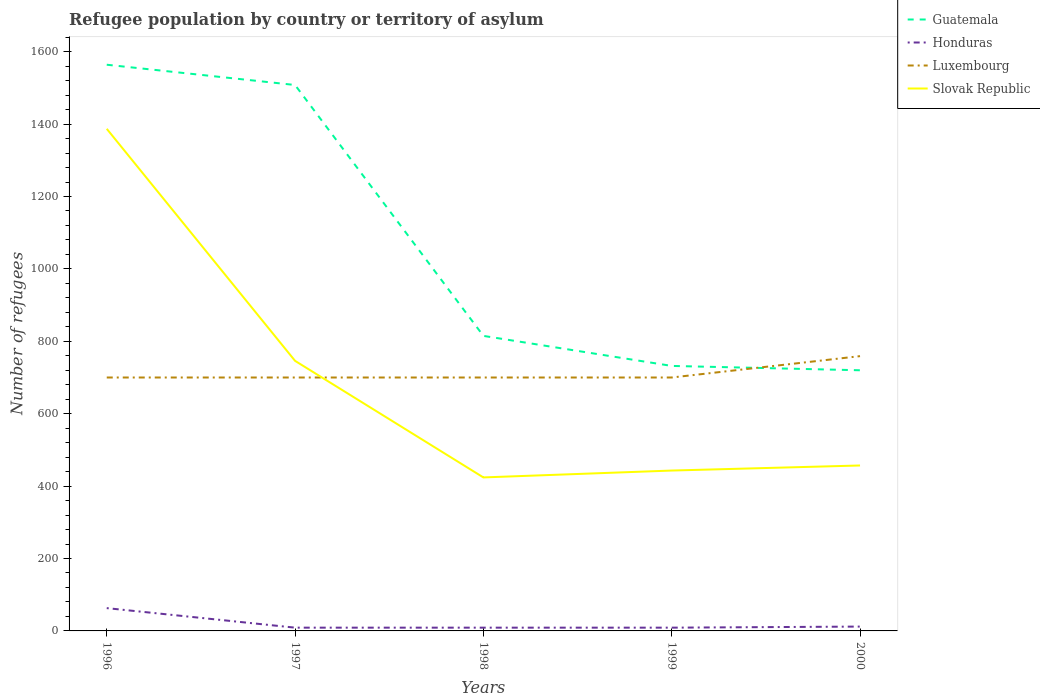Across all years, what is the maximum number of refugees in Luxembourg?
Give a very brief answer. 700. What is the difference between the highest and the second highest number of refugees in Honduras?
Provide a short and direct response. 54. How many lines are there?
Offer a very short reply. 4. What is the difference between two consecutive major ticks on the Y-axis?
Give a very brief answer. 200. Are the values on the major ticks of Y-axis written in scientific E-notation?
Make the answer very short. No. Does the graph contain grids?
Ensure brevity in your answer.  No. How many legend labels are there?
Keep it short and to the point. 4. How are the legend labels stacked?
Make the answer very short. Vertical. What is the title of the graph?
Your response must be concise. Refugee population by country or territory of asylum. What is the label or title of the X-axis?
Make the answer very short. Years. What is the label or title of the Y-axis?
Ensure brevity in your answer.  Number of refugees. What is the Number of refugees in Guatemala in 1996?
Make the answer very short. 1564. What is the Number of refugees of Honduras in 1996?
Your response must be concise. 63. What is the Number of refugees of Luxembourg in 1996?
Give a very brief answer. 700. What is the Number of refugees in Slovak Republic in 1996?
Your response must be concise. 1387. What is the Number of refugees in Guatemala in 1997?
Your response must be concise. 1508. What is the Number of refugees of Luxembourg in 1997?
Offer a very short reply. 700. What is the Number of refugees in Slovak Republic in 1997?
Offer a very short reply. 746. What is the Number of refugees in Guatemala in 1998?
Your response must be concise. 815. What is the Number of refugees in Luxembourg in 1998?
Provide a succinct answer. 700. What is the Number of refugees of Slovak Republic in 1998?
Offer a terse response. 424. What is the Number of refugees of Guatemala in 1999?
Offer a terse response. 732. What is the Number of refugees of Luxembourg in 1999?
Keep it short and to the point. 700. What is the Number of refugees of Slovak Republic in 1999?
Your answer should be compact. 443. What is the Number of refugees in Guatemala in 2000?
Offer a terse response. 720. What is the Number of refugees in Luxembourg in 2000?
Provide a succinct answer. 759. What is the Number of refugees of Slovak Republic in 2000?
Provide a succinct answer. 457. Across all years, what is the maximum Number of refugees in Guatemala?
Keep it short and to the point. 1564. Across all years, what is the maximum Number of refugees of Honduras?
Ensure brevity in your answer.  63. Across all years, what is the maximum Number of refugees of Luxembourg?
Give a very brief answer. 759. Across all years, what is the maximum Number of refugees in Slovak Republic?
Offer a terse response. 1387. Across all years, what is the minimum Number of refugees of Guatemala?
Offer a terse response. 720. Across all years, what is the minimum Number of refugees in Honduras?
Keep it short and to the point. 9. Across all years, what is the minimum Number of refugees in Luxembourg?
Keep it short and to the point. 700. Across all years, what is the minimum Number of refugees in Slovak Republic?
Ensure brevity in your answer.  424. What is the total Number of refugees of Guatemala in the graph?
Provide a succinct answer. 5339. What is the total Number of refugees of Honduras in the graph?
Your answer should be very brief. 102. What is the total Number of refugees of Luxembourg in the graph?
Make the answer very short. 3559. What is the total Number of refugees in Slovak Republic in the graph?
Give a very brief answer. 3457. What is the difference between the Number of refugees in Guatemala in 1996 and that in 1997?
Offer a very short reply. 56. What is the difference between the Number of refugees in Honduras in 1996 and that in 1997?
Provide a succinct answer. 54. What is the difference between the Number of refugees of Luxembourg in 1996 and that in 1997?
Ensure brevity in your answer.  0. What is the difference between the Number of refugees of Slovak Republic in 1996 and that in 1997?
Offer a very short reply. 641. What is the difference between the Number of refugees in Guatemala in 1996 and that in 1998?
Keep it short and to the point. 749. What is the difference between the Number of refugees of Honduras in 1996 and that in 1998?
Make the answer very short. 54. What is the difference between the Number of refugees of Slovak Republic in 1996 and that in 1998?
Offer a very short reply. 963. What is the difference between the Number of refugees in Guatemala in 1996 and that in 1999?
Provide a short and direct response. 832. What is the difference between the Number of refugees of Luxembourg in 1996 and that in 1999?
Make the answer very short. 0. What is the difference between the Number of refugees of Slovak Republic in 1996 and that in 1999?
Your response must be concise. 944. What is the difference between the Number of refugees in Guatemala in 1996 and that in 2000?
Keep it short and to the point. 844. What is the difference between the Number of refugees in Luxembourg in 1996 and that in 2000?
Offer a terse response. -59. What is the difference between the Number of refugees of Slovak Republic in 1996 and that in 2000?
Your answer should be compact. 930. What is the difference between the Number of refugees in Guatemala in 1997 and that in 1998?
Provide a succinct answer. 693. What is the difference between the Number of refugees of Honduras in 1997 and that in 1998?
Provide a succinct answer. 0. What is the difference between the Number of refugees of Slovak Republic in 1997 and that in 1998?
Offer a very short reply. 322. What is the difference between the Number of refugees in Guatemala in 1997 and that in 1999?
Offer a terse response. 776. What is the difference between the Number of refugees of Honduras in 1997 and that in 1999?
Keep it short and to the point. 0. What is the difference between the Number of refugees of Slovak Republic in 1997 and that in 1999?
Your answer should be compact. 303. What is the difference between the Number of refugees in Guatemala in 1997 and that in 2000?
Give a very brief answer. 788. What is the difference between the Number of refugees of Luxembourg in 1997 and that in 2000?
Provide a succinct answer. -59. What is the difference between the Number of refugees in Slovak Republic in 1997 and that in 2000?
Your answer should be very brief. 289. What is the difference between the Number of refugees in Guatemala in 1998 and that in 1999?
Give a very brief answer. 83. What is the difference between the Number of refugees in Honduras in 1998 and that in 1999?
Keep it short and to the point. 0. What is the difference between the Number of refugees of Luxembourg in 1998 and that in 1999?
Make the answer very short. 0. What is the difference between the Number of refugees of Slovak Republic in 1998 and that in 1999?
Make the answer very short. -19. What is the difference between the Number of refugees in Guatemala in 1998 and that in 2000?
Ensure brevity in your answer.  95. What is the difference between the Number of refugees in Honduras in 1998 and that in 2000?
Ensure brevity in your answer.  -3. What is the difference between the Number of refugees in Luxembourg in 1998 and that in 2000?
Offer a very short reply. -59. What is the difference between the Number of refugees in Slovak Republic in 1998 and that in 2000?
Make the answer very short. -33. What is the difference between the Number of refugees in Guatemala in 1999 and that in 2000?
Provide a succinct answer. 12. What is the difference between the Number of refugees of Luxembourg in 1999 and that in 2000?
Your answer should be compact. -59. What is the difference between the Number of refugees in Guatemala in 1996 and the Number of refugees in Honduras in 1997?
Offer a very short reply. 1555. What is the difference between the Number of refugees of Guatemala in 1996 and the Number of refugees of Luxembourg in 1997?
Offer a terse response. 864. What is the difference between the Number of refugees of Guatemala in 1996 and the Number of refugees of Slovak Republic in 1997?
Keep it short and to the point. 818. What is the difference between the Number of refugees of Honduras in 1996 and the Number of refugees of Luxembourg in 1997?
Make the answer very short. -637. What is the difference between the Number of refugees in Honduras in 1996 and the Number of refugees in Slovak Republic in 1997?
Your answer should be compact. -683. What is the difference between the Number of refugees of Luxembourg in 1996 and the Number of refugees of Slovak Republic in 1997?
Your answer should be very brief. -46. What is the difference between the Number of refugees of Guatemala in 1996 and the Number of refugees of Honduras in 1998?
Your response must be concise. 1555. What is the difference between the Number of refugees in Guatemala in 1996 and the Number of refugees in Luxembourg in 1998?
Your answer should be compact. 864. What is the difference between the Number of refugees of Guatemala in 1996 and the Number of refugees of Slovak Republic in 1998?
Your response must be concise. 1140. What is the difference between the Number of refugees in Honduras in 1996 and the Number of refugees in Luxembourg in 1998?
Ensure brevity in your answer.  -637. What is the difference between the Number of refugees of Honduras in 1996 and the Number of refugees of Slovak Republic in 1998?
Give a very brief answer. -361. What is the difference between the Number of refugees in Luxembourg in 1996 and the Number of refugees in Slovak Republic in 1998?
Provide a short and direct response. 276. What is the difference between the Number of refugees in Guatemala in 1996 and the Number of refugees in Honduras in 1999?
Your answer should be very brief. 1555. What is the difference between the Number of refugees in Guatemala in 1996 and the Number of refugees in Luxembourg in 1999?
Offer a terse response. 864. What is the difference between the Number of refugees of Guatemala in 1996 and the Number of refugees of Slovak Republic in 1999?
Your response must be concise. 1121. What is the difference between the Number of refugees in Honduras in 1996 and the Number of refugees in Luxembourg in 1999?
Your response must be concise. -637. What is the difference between the Number of refugees in Honduras in 1996 and the Number of refugees in Slovak Republic in 1999?
Your answer should be very brief. -380. What is the difference between the Number of refugees in Luxembourg in 1996 and the Number of refugees in Slovak Republic in 1999?
Your answer should be very brief. 257. What is the difference between the Number of refugees in Guatemala in 1996 and the Number of refugees in Honduras in 2000?
Your answer should be very brief. 1552. What is the difference between the Number of refugees of Guatemala in 1996 and the Number of refugees of Luxembourg in 2000?
Your answer should be very brief. 805. What is the difference between the Number of refugees of Guatemala in 1996 and the Number of refugees of Slovak Republic in 2000?
Provide a short and direct response. 1107. What is the difference between the Number of refugees in Honduras in 1996 and the Number of refugees in Luxembourg in 2000?
Give a very brief answer. -696. What is the difference between the Number of refugees in Honduras in 1996 and the Number of refugees in Slovak Republic in 2000?
Your answer should be compact. -394. What is the difference between the Number of refugees of Luxembourg in 1996 and the Number of refugees of Slovak Republic in 2000?
Give a very brief answer. 243. What is the difference between the Number of refugees of Guatemala in 1997 and the Number of refugees of Honduras in 1998?
Keep it short and to the point. 1499. What is the difference between the Number of refugees in Guatemala in 1997 and the Number of refugees in Luxembourg in 1998?
Your answer should be very brief. 808. What is the difference between the Number of refugees in Guatemala in 1997 and the Number of refugees in Slovak Republic in 1998?
Your answer should be compact. 1084. What is the difference between the Number of refugees in Honduras in 1997 and the Number of refugees in Luxembourg in 1998?
Offer a terse response. -691. What is the difference between the Number of refugees in Honduras in 1997 and the Number of refugees in Slovak Republic in 1998?
Keep it short and to the point. -415. What is the difference between the Number of refugees in Luxembourg in 1997 and the Number of refugees in Slovak Republic in 1998?
Ensure brevity in your answer.  276. What is the difference between the Number of refugees in Guatemala in 1997 and the Number of refugees in Honduras in 1999?
Give a very brief answer. 1499. What is the difference between the Number of refugees of Guatemala in 1997 and the Number of refugees of Luxembourg in 1999?
Give a very brief answer. 808. What is the difference between the Number of refugees of Guatemala in 1997 and the Number of refugees of Slovak Republic in 1999?
Provide a short and direct response. 1065. What is the difference between the Number of refugees of Honduras in 1997 and the Number of refugees of Luxembourg in 1999?
Make the answer very short. -691. What is the difference between the Number of refugees of Honduras in 1997 and the Number of refugees of Slovak Republic in 1999?
Keep it short and to the point. -434. What is the difference between the Number of refugees in Luxembourg in 1997 and the Number of refugees in Slovak Republic in 1999?
Your response must be concise. 257. What is the difference between the Number of refugees in Guatemala in 1997 and the Number of refugees in Honduras in 2000?
Provide a short and direct response. 1496. What is the difference between the Number of refugees of Guatemala in 1997 and the Number of refugees of Luxembourg in 2000?
Provide a short and direct response. 749. What is the difference between the Number of refugees in Guatemala in 1997 and the Number of refugees in Slovak Republic in 2000?
Give a very brief answer. 1051. What is the difference between the Number of refugees of Honduras in 1997 and the Number of refugees of Luxembourg in 2000?
Provide a short and direct response. -750. What is the difference between the Number of refugees of Honduras in 1997 and the Number of refugees of Slovak Republic in 2000?
Provide a succinct answer. -448. What is the difference between the Number of refugees of Luxembourg in 1997 and the Number of refugees of Slovak Republic in 2000?
Ensure brevity in your answer.  243. What is the difference between the Number of refugees of Guatemala in 1998 and the Number of refugees of Honduras in 1999?
Your answer should be very brief. 806. What is the difference between the Number of refugees in Guatemala in 1998 and the Number of refugees in Luxembourg in 1999?
Your answer should be very brief. 115. What is the difference between the Number of refugees in Guatemala in 1998 and the Number of refugees in Slovak Republic in 1999?
Ensure brevity in your answer.  372. What is the difference between the Number of refugees in Honduras in 1998 and the Number of refugees in Luxembourg in 1999?
Your answer should be very brief. -691. What is the difference between the Number of refugees of Honduras in 1998 and the Number of refugees of Slovak Republic in 1999?
Offer a terse response. -434. What is the difference between the Number of refugees of Luxembourg in 1998 and the Number of refugees of Slovak Republic in 1999?
Make the answer very short. 257. What is the difference between the Number of refugees in Guatemala in 1998 and the Number of refugees in Honduras in 2000?
Provide a succinct answer. 803. What is the difference between the Number of refugees of Guatemala in 1998 and the Number of refugees of Slovak Republic in 2000?
Your response must be concise. 358. What is the difference between the Number of refugees in Honduras in 1998 and the Number of refugees in Luxembourg in 2000?
Ensure brevity in your answer.  -750. What is the difference between the Number of refugees in Honduras in 1998 and the Number of refugees in Slovak Republic in 2000?
Your response must be concise. -448. What is the difference between the Number of refugees of Luxembourg in 1998 and the Number of refugees of Slovak Republic in 2000?
Give a very brief answer. 243. What is the difference between the Number of refugees of Guatemala in 1999 and the Number of refugees of Honduras in 2000?
Ensure brevity in your answer.  720. What is the difference between the Number of refugees in Guatemala in 1999 and the Number of refugees in Luxembourg in 2000?
Your response must be concise. -27. What is the difference between the Number of refugees in Guatemala in 1999 and the Number of refugees in Slovak Republic in 2000?
Your answer should be compact. 275. What is the difference between the Number of refugees in Honduras in 1999 and the Number of refugees in Luxembourg in 2000?
Offer a terse response. -750. What is the difference between the Number of refugees of Honduras in 1999 and the Number of refugees of Slovak Republic in 2000?
Make the answer very short. -448. What is the difference between the Number of refugees in Luxembourg in 1999 and the Number of refugees in Slovak Republic in 2000?
Your answer should be compact. 243. What is the average Number of refugees in Guatemala per year?
Your answer should be very brief. 1067.8. What is the average Number of refugees of Honduras per year?
Your answer should be very brief. 20.4. What is the average Number of refugees in Luxembourg per year?
Give a very brief answer. 711.8. What is the average Number of refugees of Slovak Republic per year?
Make the answer very short. 691.4. In the year 1996, what is the difference between the Number of refugees of Guatemala and Number of refugees of Honduras?
Your response must be concise. 1501. In the year 1996, what is the difference between the Number of refugees in Guatemala and Number of refugees in Luxembourg?
Give a very brief answer. 864. In the year 1996, what is the difference between the Number of refugees in Guatemala and Number of refugees in Slovak Republic?
Ensure brevity in your answer.  177. In the year 1996, what is the difference between the Number of refugees of Honduras and Number of refugees of Luxembourg?
Offer a terse response. -637. In the year 1996, what is the difference between the Number of refugees of Honduras and Number of refugees of Slovak Republic?
Your answer should be very brief. -1324. In the year 1996, what is the difference between the Number of refugees of Luxembourg and Number of refugees of Slovak Republic?
Your answer should be very brief. -687. In the year 1997, what is the difference between the Number of refugees of Guatemala and Number of refugees of Honduras?
Your answer should be very brief. 1499. In the year 1997, what is the difference between the Number of refugees of Guatemala and Number of refugees of Luxembourg?
Make the answer very short. 808. In the year 1997, what is the difference between the Number of refugees of Guatemala and Number of refugees of Slovak Republic?
Offer a terse response. 762. In the year 1997, what is the difference between the Number of refugees of Honduras and Number of refugees of Luxembourg?
Provide a succinct answer. -691. In the year 1997, what is the difference between the Number of refugees of Honduras and Number of refugees of Slovak Republic?
Your response must be concise. -737. In the year 1997, what is the difference between the Number of refugees in Luxembourg and Number of refugees in Slovak Republic?
Your answer should be compact. -46. In the year 1998, what is the difference between the Number of refugees in Guatemala and Number of refugees in Honduras?
Your answer should be compact. 806. In the year 1998, what is the difference between the Number of refugees in Guatemala and Number of refugees in Luxembourg?
Keep it short and to the point. 115. In the year 1998, what is the difference between the Number of refugees in Guatemala and Number of refugees in Slovak Republic?
Keep it short and to the point. 391. In the year 1998, what is the difference between the Number of refugees in Honduras and Number of refugees in Luxembourg?
Offer a terse response. -691. In the year 1998, what is the difference between the Number of refugees of Honduras and Number of refugees of Slovak Republic?
Ensure brevity in your answer.  -415. In the year 1998, what is the difference between the Number of refugees in Luxembourg and Number of refugees in Slovak Republic?
Give a very brief answer. 276. In the year 1999, what is the difference between the Number of refugees in Guatemala and Number of refugees in Honduras?
Offer a very short reply. 723. In the year 1999, what is the difference between the Number of refugees in Guatemala and Number of refugees in Slovak Republic?
Give a very brief answer. 289. In the year 1999, what is the difference between the Number of refugees of Honduras and Number of refugees of Luxembourg?
Provide a succinct answer. -691. In the year 1999, what is the difference between the Number of refugees in Honduras and Number of refugees in Slovak Republic?
Give a very brief answer. -434. In the year 1999, what is the difference between the Number of refugees in Luxembourg and Number of refugees in Slovak Republic?
Your answer should be very brief. 257. In the year 2000, what is the difference between the Number of refugees in Guatemala and Number of refugees in Honduras?
Your answer should be compact. 708. In the year 2000, what is the difference between the Number of refugees of Guatemala and Number of refugees of Luxembourg?
Provide a succinct answer. -39. In the year 2000, what is the difference between the Number of refugees in Guatemala and Number of refugees in Slovak Republic?
Provide a short and direct response. 263. In the year 2000, what is the difference between the Number of refugees of Honduras and Number of refugees of Luxembourg?
Give a very brief answer. -747. In the year 2000, what is the difference between the Number of refugees of Honduras and Number of refugees of Slovak Republic?
Make the answer very short. -445. In the year 2000, what is the difference between the Number of refugees of Luxembourg and Number of refugees of Slovak Republic?
Offer a very short reply. 302. What is the ratio of the Number of refugees of Guatemala in 1996 to that in 1997?
Your answer should be compact. 1.04. What is the ratio of the Number of refugees in Honduras in 1996 to that in 1997?
Make the answer very short. 7. What is the ratio of the Number of refugees in Slovak Republic in 1996 to that in 1997?
Provide a short and direct response. 1.86. What is the ratio of the Number of refugees in Guatemala in 1996 to that in 1998?
Your response must be concise. 1.92. What is the ratio of the Number of refugees of Honduras in 1996 to that in 1998?
Ensure brevity in your answer.  7. What is the ratio of the Number of refugees of Luxembourg in 1996 to that in 1998?
Give a very brief answer. 1. What is the ratio of the Number of refugees in Slovak Republic in 1996 to that in 1998?
Your answer should be compact. 3.27. What is the ratio of the Number of refugees of Guatemala in 1996 to that in 1999?
Provide a short and direct response. 2.14. What is the ratio of the Number of refugees of Honduras in 1996 to that in 1999?
Offer a terse response. 7. What is the ratio of the Number of refugees of Luxembourg in 1996 to that in 1999?
Provide a short and direct response. 1. What is the ratio of the Number of refugees in Slovak Republic in 1996 to that in 1999?
Offer a terse response. 3.13. What is the ratio of the Number of refugees in Guatemala in 1996 to that in 2000?
Keep it short and to the point. 2.17. What is the ratio of the Number of refugees in Honduras in 1996 to that in 2000?
Your answer should be compact. 5.25. What is the ratio of the Number of refugees in Luxembourg in 1996 to that in 2000?
Offer a very short reply. 0.92. What is the ratio of the Number of refugees of Slovak Republic in 1996 to that in 2000?
Provide a succinct answer. 3.04. What is the ratio of the Number of refugees in Guatemala in 1997 to that in 1998?
Keep it short and to the point. 1.85. What is the ratio of the Number of refugees in Slovak Republic in 1997 to that in 1998?
Your response must be concise. 1.76. What is the ratio of the Number of refugees in Guatemala in 1997 to that in 1999?
Ensure brevity in your answer.  2.06. What is the ratio of the Number of refugees in Slovak Republic in 1997 to that in 1999?
Offer a very short reply. 1.68. What is the ratio of the Number of refugees of Guatemala in 1997 to that in 2000?
Your answer should be very brief. 2.09. What is the ratio of the Number of refugees in Honduras in 1997 to that in 2000?
Offer a terse response. 0.75. What is the ratio of the Number of refugees in Luxembourg in 1997 to that in 2000?
Your answer should be compact. 0.92. What is the ratio of the Number of refugees of Slovak Republic in 1997 to that in 2000?
Offer a very short reply. 1.63. What is the ratio of the Number of refugees of Guatemala in 1998 to that in 1999?
Give a very brief answer. 1.11. What is the ratio of the Number of refugees of Honduras in 1998 to that in 1999?
Provide a short and direct response. 1. What is the ratio of the Number of refugees of Slovak Republic in 1998 to that in 1999?
Ensure brevity in your answer.  0.96. What is the ratio of the Number of refugees of Guatemala in 1998 to that in 2000?
Make the answer very short. 1.13. What is the ratio of the Number of refugees in Honduras in 1998 to that in 2000?
Your response must be concise. 0.75. What is the ratio of the Number of refugees in Luxembourg in 1998 to that in 2000?
Your response must be concise. 0.92. What is the ratio of the Number of refugees of Slovak Republic in 1998 to that in 2000?
Your response must be concise. 0.93. What is the ratio of the Number of refugees of Guatemala in 1999 to that in 2000?
Provide a short and direct response. 1.02. What is the ratio of the Number of refugees of Honduras in 1999 to that in 2000?
Provide a succinct answer. 0.75. What is the ratio of the Number of refugees in Luxembourg in 1999 to that in 2000?
Give a very brief answer. 0.92. What is the ratio of the Number of refugees of Slovak Republic in 1999 to that in 2000?
Give a very brief answer. 0.97. What is the difference between the highest and the second highest Number of refugees in Luxembourg?
Provide a succinct answer. 59. What is the difference between the highest and the second highest Number of refugees in Slovak Republic?
Keep it short and to the point. 641. What is the difference between the highest and the lowest Number of refugees in Guatemala?
Provide a short and direct response. 844. What is the difference between the highest and the lowest Number of refugees of Luxembourg?
Keep it short and to the point. 59. What is the difference between the highest and the lowest Number of refugees in Slovak Republic?
Your answer should be very brief. 963. 